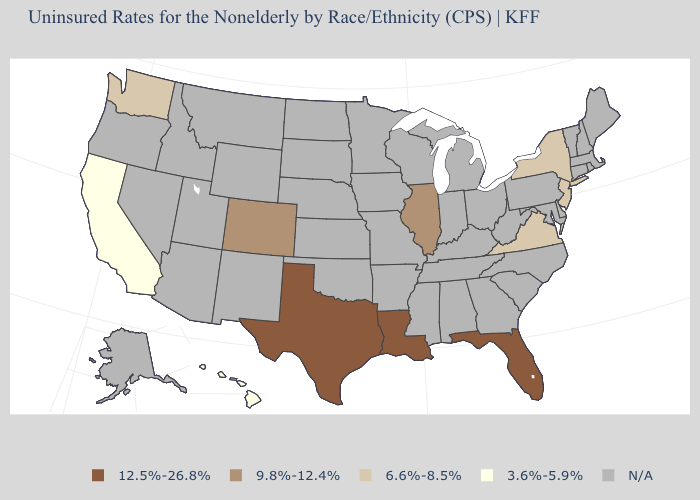Does Florida have the highest value in the USA?
Keep it brief. Yes. What is the value of Minnesota?
Write a very short answer. N/A. What is the value of North Dakota?
Answer briefly. N/A. Name the states that have a value in the range 12.5%-26.8%?
Answer briefly. Florida, Louisiana, Texas. Is the legend a continuous bar?
Answer briefly. No. Does the first symbol in the legend represent the smallest category?
Concise answer only. No. What is the value of Oklahoma?
Be succinct. N/A. Name the states that have a value in the range 12.5%-26.8%?
Concise answer only. Florida, Louisiana, Texas. Name the states that have a value in the range N/A?
Be succinct. Alabama, Alaska, Arizona, Arkansas, Connecticut, Delaware, Georgia, Idaho, Indiana, Iowa, Kansas, Kentucky, Maine, Maryland, Massachusetts, Michigan, Minnesota, Mississippi, Missouri, Montana, Nebraska, Nevada, New Hampshire, New Mexico, North Carolina, North Dakota, Ohio, Oklahoma, Oregon, Pennsylvania, Rhode Island, South Carolina, South Dakota, Tennessee, Utah, Vermont, West Virginia, Wisconsin, Wyoming. What is the lowest value in the West?
Give a very brief answer. 3.6%-5.9%. Does New Jersey have the highest value in the USA?
Give a very brief answer. No. Name the states that have a value in the range 9.8%-12.4%?
Keep it brief. Colorado, Illinois. Which states hav the highest value in the West?
Keep it brief. Colorado. 